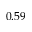<formula> <loc_0><loc_0><loc_500><loc_500>0 . 5 9</formula> 